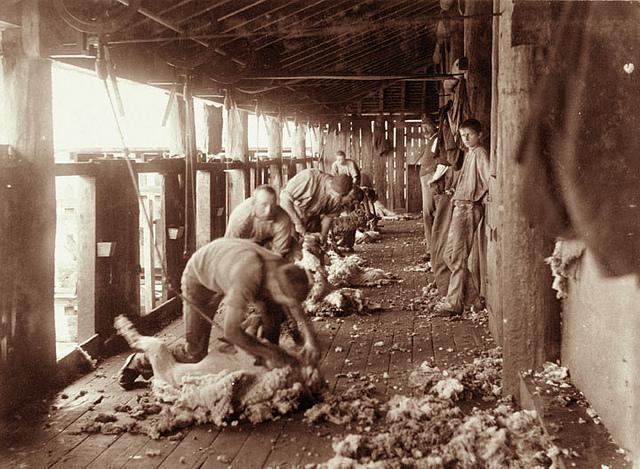How many people are there?
Give a very brief answer. 5. How many sheep are there?
Give a very brief answer. 2. How many televisions are on the left of the door?
Give a very brief answer. 0. 